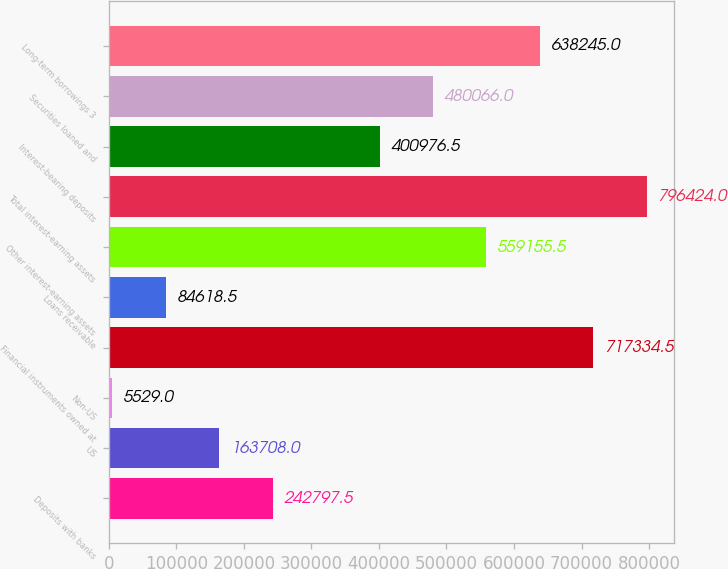Convert chart to OTSL. <chart><loc_0><loc_0><loc_500><loc_500><bar_chart><fcel>Deposits with banks<fcel>US<fcel>Non-US<fcel>Financial instruments owned at<fcel>Loans receivable<fcel>Other interest-earning assets<fcel>Total interest-earning assets<fcel>Interest-bearing deposits<fcel>Securities loaned and<fcel>Long-term borrowings 3<nl><fcel>242798<fcel>163708<fcel>5529<fcel>717334<fcel>84618.5<fcel>559156<fcel>796424<fcel>400976<fcel>480066<fcel>638245<nl></chart> 